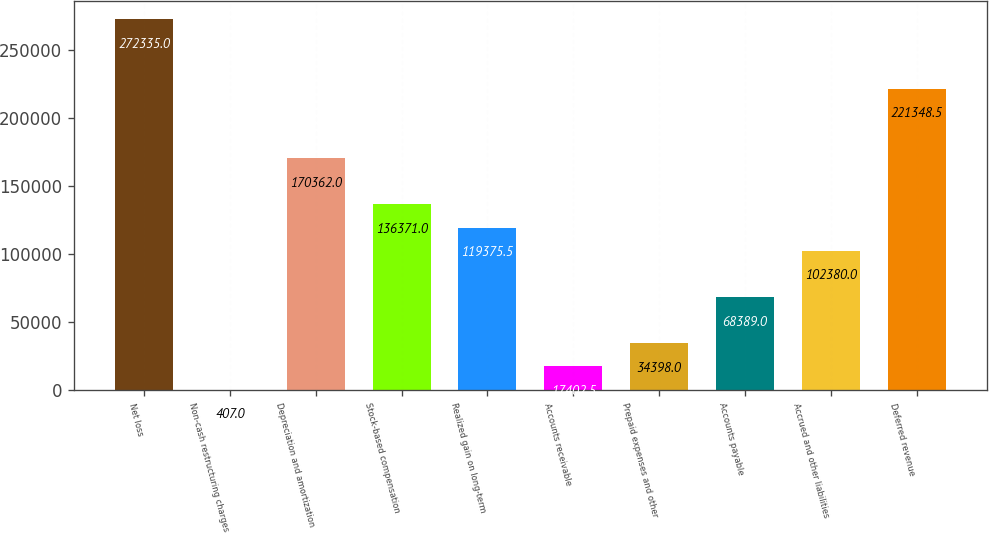<chart> <loc_0><loc_0><loc_500><loc_500><bar_chart><fcel>Net loss<fcel>Non-cash restructuring charges<fcel>Depreciation and amortization<fcel>Stock-based compensation<fcel>Realized gain on long-term<fcel>Accounts receivable<fcel>Prepaid expenses and other<fcel>Accounts payable<fcel>Accrued and other liabilities<fcel>Deferred revenue<nl><fcel>272335<fcel>407<fcel>170362<fcel>136371<fcel>119376<fcel>17402.5<fcel>34398<fcel>68389<fcel>102380<fcel>221348<nl></chart> 